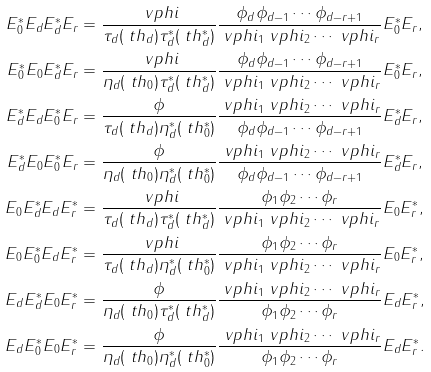<formula> <loc_0><loc_0><loc_500><loc_500>E ^ { * } _ { 0 } E _ { d } E ^ { * } _ { d } E _ { r } & = \frac { \ v p h i } { \tau _ { d } ( \ t h _ { d } ) \tau ^ { * } _ { d } ( \ t h ^ { * } _ { d } ) } \frac { \phi _ { d } \phi _ { d - 1 } \cdots \phi _ { d - r + 1 } } { \ v p h i _ { 1 } \ v p h i _ { 2 } \cdots \ v p h i _ { r } } E ^ { * } _ { 0 } E _ { r } , \\ E ^ { * } _ { 0 } E _ { 0 } E ^ { * } _ { d } E _ { r } & = \frac { \ v p h i } { \eta _ { d } ( \ t h _ { 0 } ) \tau ^ { * } _ { d } ( \ t h ^ { * } _ { d } ) } \frac { \phi _ { d } \phi _ { d - 1 } \cdots \phi _ { d - r + 1 } } { \ v p h i _ { 1 } \ v p h i _ { 2 } \cdots \ v p h i _ { r } } E ^ { * } _ { 0 } E _ { r } , \\ E ^ { * } _ { d } E _ { d } E ^ { * } _ { 0 } E _ { r } & = \frac { \phi } { \tau _ { d } ( \ t h _ { d } ) \eta ^ { * } _ { d } ( \ t h ^ { * } _ { 0 } ) } \frac { \ v p h i _ { 1 } \ v p h i _ { 2 } \cdots \ v p h i _ { r } } { \phi _ { d } \phi _ { d - 1 } \cdots \phi _ { d - r + 1 } } E ^ { * } _ { d } E _ { r } , \\ E ^ { * } _ { d } E _ { 0 } E ^ { * } _ { 0 } E _ { r } & = \frac { \phi } { \eta _ { d } ( \ t h _ { 0 } ) \eta ^ { * } _ { d } ( \ t h ^ { * } _ { 0 } ) } \frac { \ v p h i _ { 1 } \ v p h i _ { 2 } \cdots \ v p h i _ { r } } { \phi _ { d } \phi _ { d - 1 } \cdots \phi _ { d - r + 1 } } E ^ { * } _ { d } E _ { r } , \\ E _ { 0 } E ^ { * } _ { d } E _ { d } E ^ { * } _ { r } & = \frac { \ v p h i } { \tau _ { d } ( \ t h _ { d } ) \tau ^ { * } _ { d } ( \ t h ^ { * } _ { d } ) } \frac { \phi _ { 1 } \phi _ { 2 } \cdots \phi _ { r } } { \ v p h i _ { 1 } \ v p h i _ { 2 } \cdots \ v p h i _ { r } } E _ { 0 } E ^ { * } _ { r } , \\ E _ { 0 } E ^ { * } _ { 0 } E _ { d } E ^ { * } _ { r } & = \frac { \ v p h i } { \tau _ { d } ( \ t h _ { d } ) \eta ^ { * } _ { d } ( \ t h ^ { * } _ { 0 } ) } \frac { \phi _ { 1 } \phi _ { 2 } \cdots \phi _ { r } } { \ v p h i _ { 1 } \ v p h i _ { 2 } \cdots \ v p h i _ { r } } E _ { 0 } E ^ { * } _ { r } , \\ E _ { d } E ^ { * } _ { d } E _ { 0 } E ^ { * } _ { r } & = \frac { \phi } { \eta _ { d } ( \ t h _ { 0 } ) \tau ^ { * } _ { d } ( \ t h ^ { * } _ { d } ) } \frac { \ v p h i _ { 1 } \ v p h i _ { 2 } \cdots \ v p h i _ { r } } { \phi _ { 1 } \phi _ { 2 } \cdots \phi _ { r } } E _ { d } E ^ { * } _ { r } , \\ E _ { d } E ^ { * } _ { 0 } E _ { 0 } E ^ { * } _ { r } & = \frac { \phi } { \eta _ { d } ( \ t h _ { 0 } ) \eta ^ { * } _ { d } ( \ t h ^ { * } _ { 0 } ) } \frac { \ v p h i _ { 1 } \ v p h i _ { 2 } \cdots \ v p h i _ { r } } { \phi _ { 1 } \phi _ { 2 } \cdots \phi _ { r } } E _ { d } E ^ { * } _ { r } .</formula> 